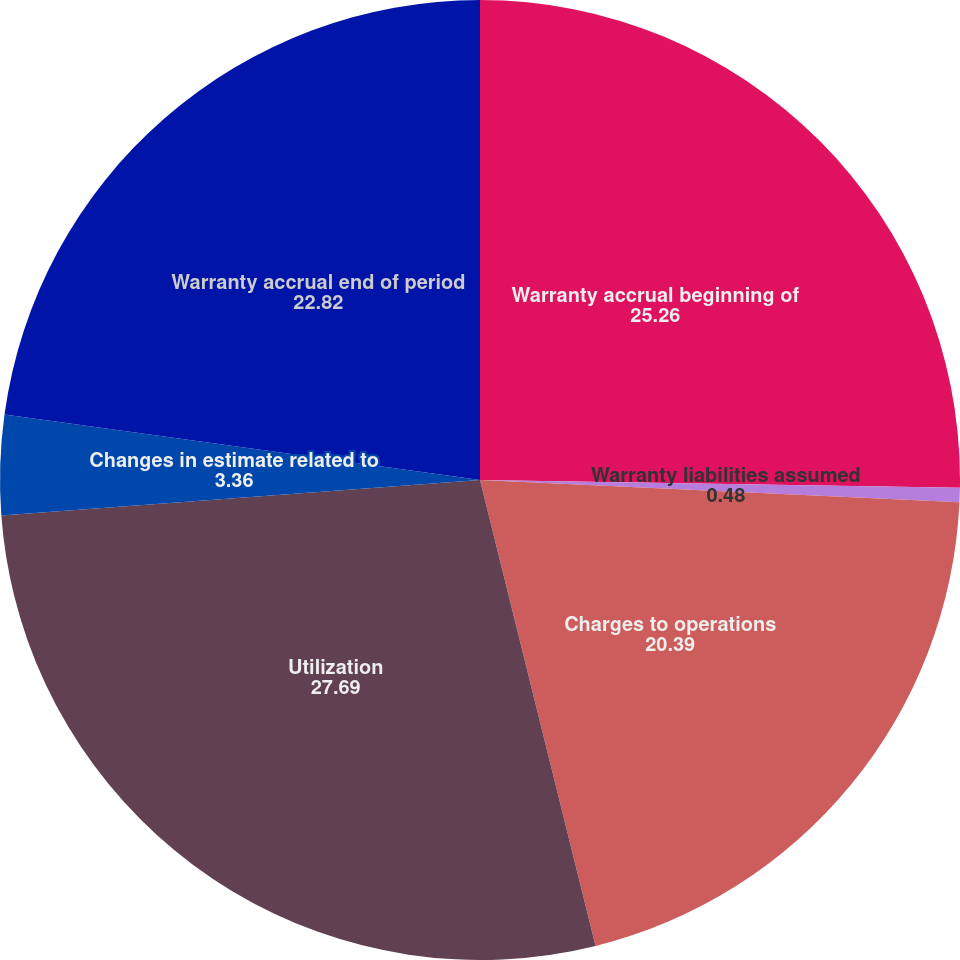<chart> <loc_0><loc_0><loc_500><loc_500><pie_chart><fcel>Warranty accrual beginning of<fcel>Warranty liabilities assumed<fcel>Charges to operations<fcel>Utilization<fcel>Changes in estimate related to<fcel>Warranty accrual end of period<nl><fcel>25.26%<fcel>0.48%<fcel>20.39%<fcel>27.69%<fcel>3.36%<fcel>22.82%<nl></chart> 